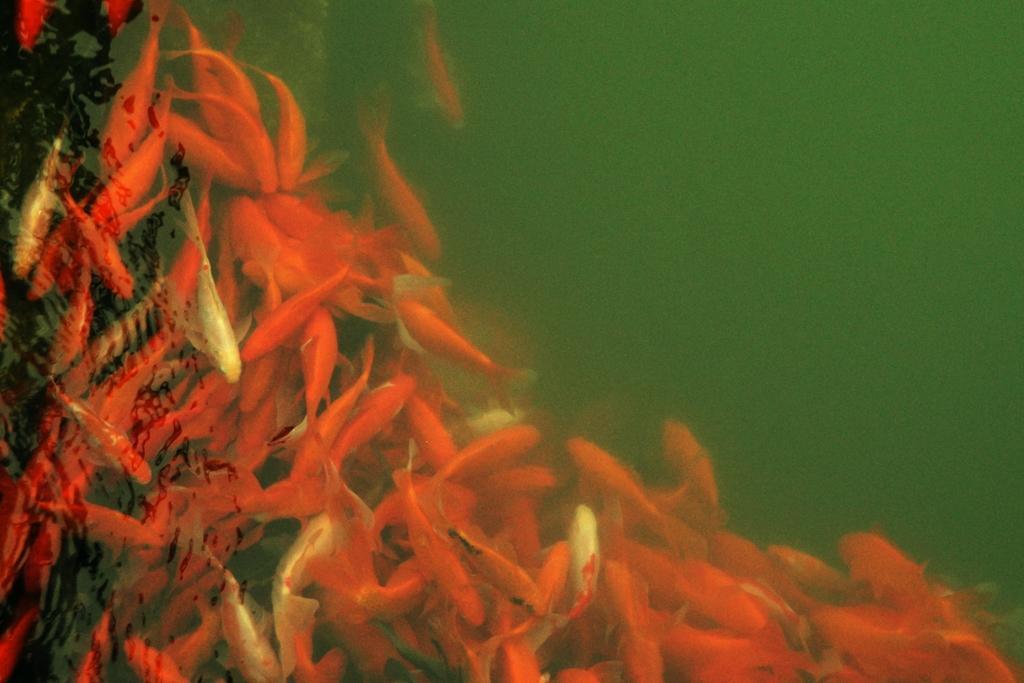How would you summarize this image in a sentence or two? There are orange fishes in the water. 